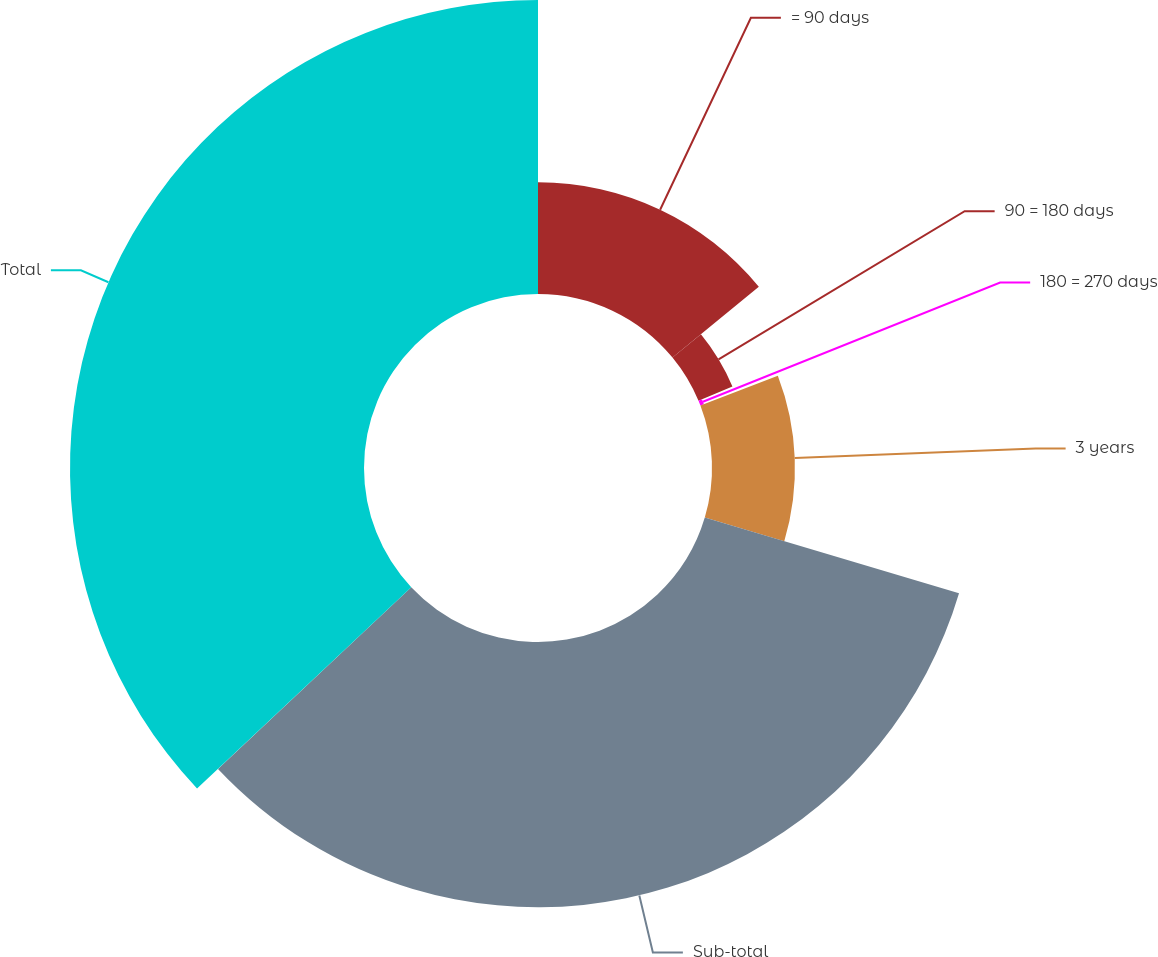Convert chart. <chart><loc_0><loc_0><loc_500><loc_500><pie_chart><fcel>= 90 days<fcel>90 = 180 days<fcel>180 = 270 days<fcel>3 years<fcel>Sub-total<fcel>Total<nl><fcel>14.06%<fcel>4.63%<fcel>0.47%<fcel>10.44%<fcel>33.39%<fcel>37.01%<nl></chart> 